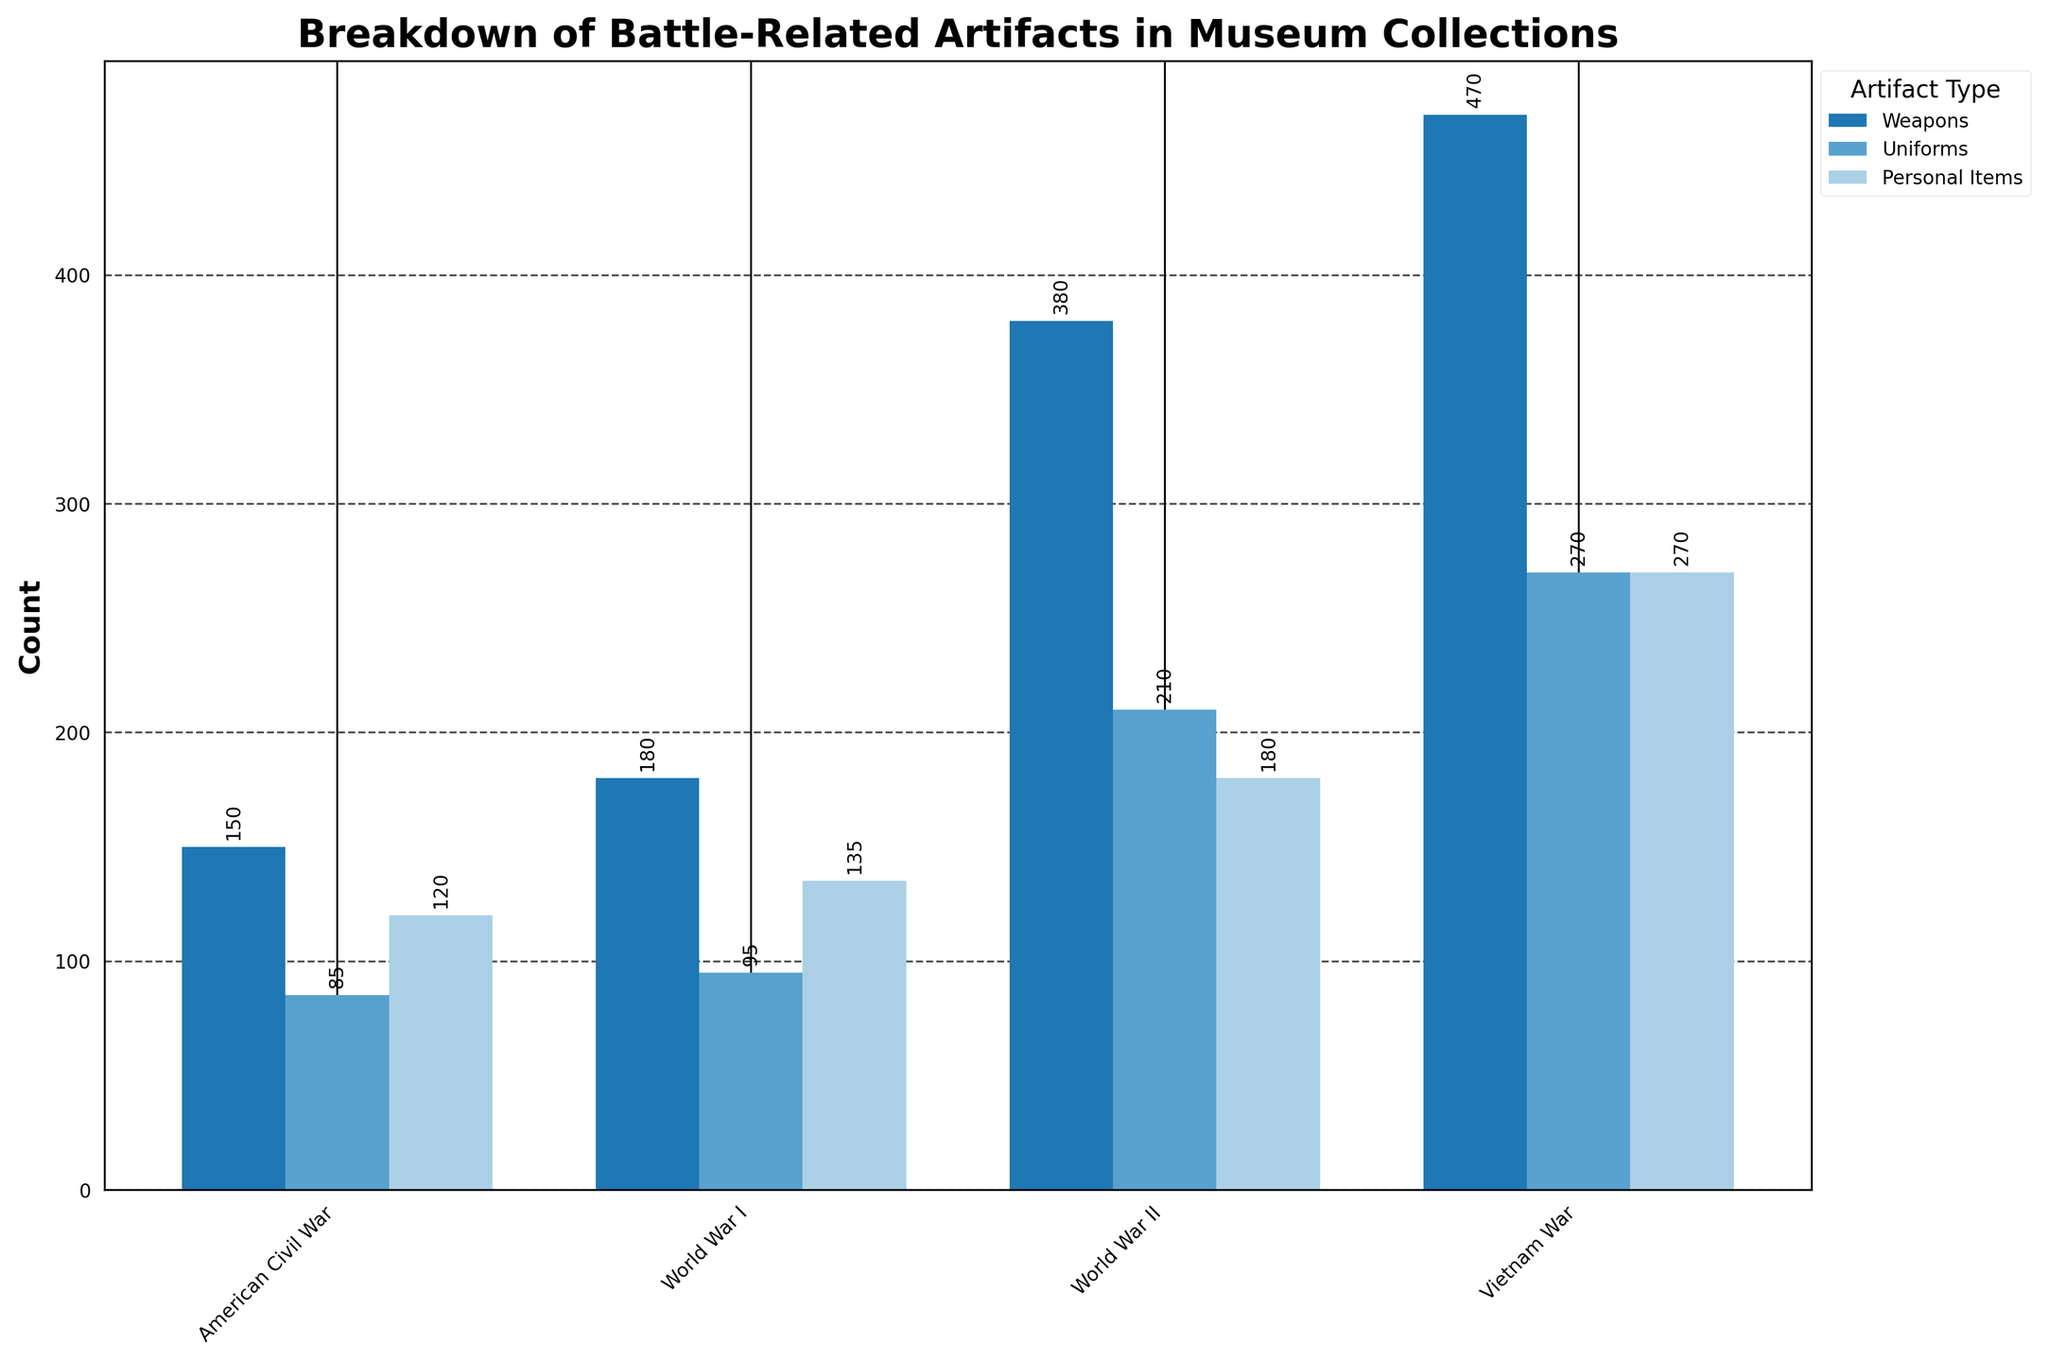What is the title of the figure? The title of the figure is typically shown at the top of the plot, labeled as such. In this case, the title is 'Breakdown of Battle-Related Artifacts in Museum Collections'
Answer: Breakdown of Battle-Related Artifacts in Museum Collections What are the artifact types analyzed in the figure? The artifact types are indicated in the legend, which is labeled as 'Artifact Type'. The artifact types are Weapons, Uniforms, and Personal Items.
Answer: Weapons, Uniforms, Personal Items Which country contributed the most weapons for World War I according to the figure? To determine this, look at the bar heights for 'Weapons' under World War I for each country. The highest bar corresponds to the country with the most weapons.
Answer: France How do the total counts of artifacts for the American Civil War compare to the Vietnam War? Sum up the counts of all artifact types for each war. For the American Civil War: 150 (Weapons) + 85 (Uniforms) + 120 (Personal Items) = 355. For the Vietnam War: 180 (Weapons) + 95 (Uniforms) + 135 (Personal Items) = 410. Compare the total counts.
Answer: Vietnam War has more artifacts Which war has the highest total count of Personal Items and what is the count? Look at the height of the 'Personal Items' bar for each war. The highest bar indicates the war with the most personal items. The counts are labeled on the bars or can be inferred from the heights.
Answer: World War II, 160 Comparing the counts of Uniforms, which war has the least representation? Check the height of the 'Uniforms' bars for each war. Identify the war with the shortest bar.
Answer: American Civil War For the Vietnam War, what is the difference between the counts of Weapons and Uniforms? Subtract the count of Uniforms from the count of Weapons for the Vietnam War. That is, 180 (Weapons) - 95 (Uniforms).
Answer: 85 In which war did the UK have more artifacts than Japan? Compare the heights of the bars for each artifact type between the UK and Japan for World War II.
Answer: World War II How does the count of Weapons in World War II compare across the UK and Japan? Look at the bars for 'Weapons' under World War II for the UK and Japan. The heights or labeled counts will show the comparison.
Answer: UK has more weapons than Japan Which country has the lowest count of battle-related artifacts for World War I? Look at the sum of the bar heights for each country in World War I. The country with the lowest sum has the least artifacts. Germany: 180 (Weapons) + 100 (Uniforms) + 85 (Personal Items) = 365, France: 200 (Weapons) + 110 (Uniforms) + 95 (Personal Items) = 405.
Answer: Germany 